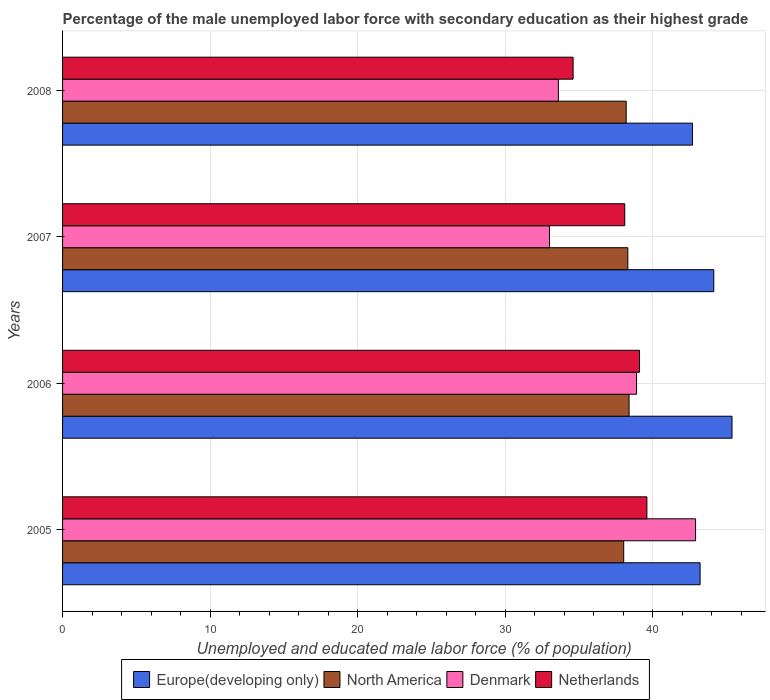How many different coloured bars are there?
Keep it short and to the point. 4. How many bars are there on the 3rd tick from the top?
Provide a short and direct response. 4. How many bars are there on the 3rd tick from the bottom?
Keep it short and to the point. 4. What is the label of the 4th group of bars from the top?
Your response must be concise. 2005. What is the percentage of the unemployed male labor force with secondary education in Europe(developing only) in 2007?
Make the answer very short. 44.13. Across all years, what is the maximum percentage of the unemployed male labor force with secondary education in Denmark?
Offer a very short reply. 42.9. Across all years, what is the minimum percentage of the unemployed male labor force with secondary education in Netherlands?
Your answer should be very brief. 34.6. In which year was the percentage of the unemployed male labor force with secondary education in North America maximum?
Your response must be concise. 2006. What is the total percentage of the unemployed male labor force with secondary education in North America in the graph?
Your response must be concise. 152.93. What is the difference between the percentage of the unemployed male labor force with secondary education in Europe(developing only) in 2005 and that in 2006?
Ensure brevity in your answer.  -2.16. What is the difference between the percentage of the unemployed male labor force with secondary education in Denmark in 2008 and the percentage of the unemployed male labor force with secondary education in North America in 2007?
Your response must be concise. -4.71. What is the average percentage of the unemployed male labor force with secondary education in Denmark per year?
Offer a very short reply. 37.1. In the year 2005, what is the difference between the percentage of the unemployed male labor force with secondary education in Europe(developing only) and percentage of the unemployed male labor force with secondary education in Denmark?
Provide a succinct answer. 0.31. What is the ratio of the percentage of the unemployed male labor force with secondary education in Denmark in 2006 to that in 2008?
Offer a terse response. 1.16. Is the difference between the percentage of the unemployed male labor force with secondary education in Europe(developing only) in 2005 and 2008 greater than the difference between the percentage of the unemployed male labor force with secondary education in Denmark in 2005 and 2008?
Provide a succinct answer. No. What is the difference between the highest and the second highest percentage of the unemployed male labor force with secondary education in Europe(developing only)?
Your response must be concise. 1.24. What is the difference between the highest and the lowest percentage of the unemployed male labor force with secondary education in Denmark?
Offer a terse response. 9.9. In how many years, is the percentage of the unemployed male labor force with secondary education in Denmark greater than the average percentage of the unemployed male labor force with secondary education in Denmark taken over all years?
Provide a short and direct response. 2. How many bars are there?
Keep it short and to the point. 16. Are all the bars in the graph horizontal?
Your answer should be very brief. Yes. Are the values on the major ticks of X-axis written in scientific E-notation?
Provide a short and direct response. No. Does the graph contain any zero values?
Provide a succinct answer. No. Does the graph contain grids?
Make the answer very short. Yes. Where does the legend appear in the graph?
Make the answer very short. Bottom center. How many legend labels are there?
Your response must be concise. 4. How are the legend labels stacked?
Make the answer very short. Horizontal. What is the title of the graph?
Offer a very short reply. Percentage of the male unemployed labor force with secondary education as their highest grade. What is the label or title of the X-axis?
Make the answer very short. Unemployed and educated male labor force (% of population). What is the label or title of the Y-axis?
Keep it short and to the point. Years. What is the Unemployed and educated male labor force (% of population) of Europe(developing only) in 2005?
Your answer should be very brief. 43.21. What is the Unemployed and educated male labor force (% of population) in North America in 2005?
Ensure brevity in your answer.  38.03. What is the Unemployed and educated male labor force (% of population) in Denmark in 2005?
Provide a short and direct response. 42.9. What is the Unemployed and educated male labor force (% of population) of Netherlands in 2005?
Your answer should be very brief. 39.6. What is the Unemployed and educated male labor force (% of population) in Europe(developing only) in 2006?
Your answer should be compact. 45.37. What is the Unemployed and educated male labor force (% of population) in North America in 2006?
Your answer should be compact. 38.39. What is the Unemployed and educated male labor force (% of population) of Denmark in 2006?
Offer a terse response. 38.9. What is the Unemployed and educated male labor force (% of population) of Netherlands in 2006?
Provide a succinct answer. 39.1. What is the Unemployed and educated male labor force (% of population) in Europe(developing only) in 2007?
Offer a very short reply. 44.13. What is the Unemployed and educated male labor force (% of population) in North America in 2007?
Your answer should be compact. 38.31. What is the Unemployed and educated male labor force (% of population) in Denmark in 2007?
Ensure brevity in your answer.  33. What is the Unemployed and educated male labor force (% of population) in Netherlands in 2007?
Offer a very short reply. 38.1. What is the Unemployed and educated male labor force (% of population) of Europe(developing only) in 2008?
Give a very brief answer. 42.69. What is the Unemployed and educated male labor force (% of population) in North America in 2008?
Provide a succinct answer. 38.2. What is the Unemployed and educated male labor force (% of population) of Denmark in 2008?
Your answer should be compact. 33.6. What is the Unemployed and educated male labor force (% of population) of Netherlands in 2008?
Your answer should be compact. 34.6. Across all years, what is the maximum Unemployed and educated male labor force (% of population) in Europe(developing only)?
Give a very brief answer. 45.37. Across all years, what is the maximum Unemployed and educated male labor force (% of population) in North America?
Provide a succinct answer. 38.39. Across all years, what is the maximum Unemployed and educated male labor force (% of population) of Denmark?
Your answer should be compact. 42.9. Across all years, what is the maximum Unemployed and educated male labor force (% of population) of Netherlands?
Ensure brevity in your answer.  39.6. Across all years, what is the minimum Unemployed and educated male labor force (% of population) of Europe(developing only)?
Give a very brief answer. 42.69. Across all years, what is the minimum Unemployed and educated male labor force (% of population) in North America?
Offer a terse response. 38.03. Across all years, what is the minimum Unemployed and educated male labor force (% of population) of Netherlands?
Provide a succinct answer. 34.6. What is the total Unemployed and educated male labor force (% of population) of Europe(developing only) in the graph?
Provide a short and direct response. 175.4. What is the total Unemployed and educated male labor force (% of population) in North America in the graph?
Keep it short and to the point. 152.93. What is the total Unemployed and educated male labor force (% of population) in Denmark in the graph?
Offer a very short reply. 148.4. What is the total Unemployed and educated male labor force (% of population) in Netherlands in the graph?
Offer a terse response. 151.4. What is the difference between the Unemployed and educated male labor force (% of population) of Europe(developing only) in 2005 and that in 2006?
Your answer should be very brief. -2.16. What is the difference between the Unemployed and educated male labor force (% of population) of North America in 2005 and that in 2006?
Offer a terse response. -0.36. What is the difference between the Unemployed and educated male labor force (% of population) of Europe(developing only) in 2005 and that in 2007?
Provide a short and direct response. -0.93. What is the difference between the Unemployed and educated male labor force (% of population) of North America in 2005 and that in 2007?
Your response must be concise. -0.28. What is the difference between the Unemployed and educated male labor force (% of population) of Denmark in 2005 and that in 2007?
Your answer should be compact. 9.9. What is the difference between the Unemployed and educated male labor force (% of population) of Europe(developing only) in 2005 and that in 2008?
Make the answer very short. 0.52. What is the difference between the Unemployed and educated male labor force (% of population) of North America in 2005 and that in 2008?
Provide a short and direct response. -0.17. What is the difference between the Unemployed and educated male labor force (% of population) of Europe(developing only) in 2006 and that in 2007?
Make the answer very short. 1.24. What is the difference between the Unemployed and educated male labor force (% of population) in North America in 2006 and that in 2007?
Keep it short and to the point. 0.08. What is the difference between the Unemployed and educated male labor force (% of population) in Denmark in 2006 and that in 2007?
Keep it short and to the point. 5.9. What is the difference between the Unemployed and educated male labor force (% of population) of Europe(developing only) in 2006 and that in 2008?
Provide a succinct answer. 2.68. What is the difference between the Unemployed and educated male labor force (% of population) in North America in 2006 and that in 2008?
Provide a short and direct response. 0.2. What is the difference between the Unemployed and educated male labor force (% of population) of Denmark in 2006 and that in 2008?
Make the answer very short. 5.3. What is the difference between the Unemployed and educated male labor force (% of population) of Europe(developing only) in 2007 and that in 2008?
Your answer should be very brief. 1.45. What is the difference between the Unemployed and educated male labor force (% of population) in North America in 2007 and that in 2008?
Provide a short and direct response. 0.11. What is the difference between the Unemployed and educated male labor force (% of population) of Netherlands in 2007 and that in 2008?
Provide a short and direct response. 3.5. What is the difference between the Unemployed and educated male labor force (% of population) of Europe(developing only) in 2005 and the Unemployed and educated male labor force (% of population) of North America in 2006?
Provide a short and direct response. 4.81. What is the difference between the Unemployed and educated male labor force (% of population) of Europe(developing only) in 2005 and the Unemployed and educated male labor force (% of population) of Denmark in 2006?
Make the answer very short. 4.31. What is the difference between the Unemployed and educated male labor force (% of population) of Europe(developing only) in 2005 and the Unemployed and educated male labor force (% of population) of Netherlands in 2006?
Offer a very short reply. 4.11. What is the difference between the Unemployed and educated male labor force (% of population) in North America in 2005 and the Unemployed and educated male labor force (% of population) in Denmark in 2006?
Keep it short and to the point. -0.87. What is the difference between the Unemployed and educated male labor force (% of population) in North America in 2005 and the Unemployed and educated male labor force (% of population) in Netherlands in 2006?
Your answer should be compact. -1.07. What is the difference between the Unemployed and educated male labor force (% of population) in Europe(developing only) in 2005 and the Unemployed and educated male labor force (% of population) in North America in 2007?
Your answer should be compact. 4.9. What is the difference between the Unemployed and educated male labor force (% of population) of Europe(developing only) in 2005 and the Unemployed and educated male labor force (% of population) of Denmark in 2007?
Your answer should be compact. 10.21. What is the difference between the Unemployed and educated male labor force (% of population) of Europe(developing only) in 2005 and the Unemployed and educated male labor force (% of population) of Netherlands in 2007?
Your answer should be compact. 5.11. What is the difference between the Unemployed and educated male labor force (% of population) of North America in 2005 and the Unemployed and educated male labor force (% of population) of Denmark in 2007?
Your response must be concise. 5.03. What is the difference between the Unemployed and educated male labor force (% of population) of North America in 2005 and the Unemployed and educated male labor force (% of population) of Netherlands in 2007?
Your response must be concise. -0.07. What is the difference between the Unemployed and educated male labor force (% of population) of Europe(developing only) in 2005 and the Unemployed and educated male labor force (% of population) of North America in 2008?
Give a very brief answer. 5.01. What is the difference between the Unemployed and educated male labor force (% of population) of Europe(developing only) in 2005 and the Unemployed and educated male labor force (% of population) of Denmark in 2008?
Provide a short and direct response. 9.61. What is the difference between the Unemployed and educated male labor force (% of population) in Europe(developing only) in 2005 and the Unemployed and educated male labor force (% of population) in Netherlands in 2008?
Offer a terse response. 8.61. What is the difference between the Unemployed and educated male labor force (% of population) in North America in 2005 and the Unemployed and educated male labor force (% of population) in Denmark in 2008?
Offer a very short reply. 4.43. What is the difference between the Unemployed and educated male labor force (% of population) in North America in 2005 and the Unemployed and educated male labor force (% of population) in Netherlands in 2008?
Give a very brief answer. 3.43. What is the difference between the Unemployed and educated male labor force (% of population) of Europe(developing only) in 2006 and the Unemployed and educated male labor force (% of population) of North America in 2007?
Your response must be concise. 7.06. What is the difference between the Unemployed and educated male labor force (% of population) of Europe(developing only) in 2006 and the Unemployed and educated male labor force (% of population) of Denmark in 2007?
Give a very brief answer. 12.37. What is the difference between the Unemployed and educated male labor force (% of population) in Europe(developing only) in 2006 and the Unemployed and educated male labor force (% of population) in Netherlands in 2007?
Offer a terse response. 7.27. What is the difference between the Unemployed and educated male labor force (% of population) of North America in 2006 and the Unemployed and educated male labor force (% of population) of Denmark in 2007?
Ensure brevity in your answer.  5.39. What is the difference between the Unemployed and educated male labor force (% of population) of North America in 2006 and the Unemployed and educated male labor force (% of population) of Netherlands in 2007?
Your answer should be compact. 0.29. What is the difference between the Unemployed and educated male labor force (% of population) in Europe(developing only) in 2006 and the Unemployed and educated male labor force (% of population) in North America in 2008?
Provide a succinct answer. 7.17. What is the difference between the Unemployed and educated male labor force (% of population) of Europe(developing only) in 2006 and the Unemployed and educated male labor force (% of population) of Denmark in 2008?
Your response must be concise. 11.77. What is the difference between the Unemployed and educated male labor force (% of population) in Europe(developing only) in 2006 and the Unemployed and educated male labor force (% of population) in Netherlands in 2008?
Give a very brief answer. 10.77. What is the difference between the Unemployed and educated male labor force (% of population) in North America in 2006 and the Unemployed and educated male labor force (% of population) in Denmark in 2008?
Make the answer very short. 4.79. What is the difference between the Unemployed and educated male labor force (% of population) in North America in 2006 and the Unemployed and educated male labor force (% of population) in Netherlands in 2008?
Ensure brevity in your answer.  3.79. What is the difference between the Unemployed and educated male labor force (% of population) in Europe(developing only) in 2007 and the Unemployed and educated male labor force (% of population) in North America in 2008?
Offer a terse response. 5.94. What is the difference between the Unemployed and educated male labor force (% of population) in Europe(developing only) in 2007 and the Unemployed and educated male labor force (% of population) in Denmark in 2008?
Give a very brief answer. 10.53. What is the difference between the Unemployed and educated male labor force (% of population) of Europe(developing only) in 2007 and the Unemployed and educated male labor force (% of population) of Netherlands in 2008?
Give a very brief answer. 9.53. What is the difference between the Unemployed and educated male labor force (% of population) of North America in 2007 and the Unemployed and educated male labor force (% of population) of Denmark in 2008?
Make the answer very short. 4.71. What is the difference between the Unemployed and educated male labor force (% of population) in North America in 2007 and the Unemployed and educated male labor force (% of population) in Netherlands in 2008?
Your answer should be compact. 3.71. What is the average Unemployed and educated male labor force (% of population) of Europe(developing only) per year?
Offer a terse response. 43.85. What is the average Unemployed and educated male labor force (% of population) of North America per year?
Keep it short and to the point. 38.23. What is the average Unemployed and educated male labor force (% of population) of Denmark per year?
Ensure brevity in your answer.  37.1. What is the average Unemployed and educated male labor force (% of population) in Netherlands per year?
Your response must be concise. 37.85. In the year 2005, what is the difference between the Unemployed and educated male labor force (% of population) of Europe(developing only) and Unemployed and educated male labor force (% of population) of North America?
Offer a terse response. 5.18. In the year 2005, what is the difference between the Unemployed and educated male labor force (% of population) in Europe(developing only) and Unemployed and educated male labor force (% of population) in Denmark?
Ensure brevity in your answer.  0.31. In the year 2005, what is the difference between the Unemployed and educated male labor force (% of population) of Europe(developing only) and Unemployed and educated male labor force (% of population) of Netherlands?
Provide a short and direct response. 3.61. In the year 2005, what is the difference between the Unemployed and educated male labor force (% of population) of North America and Unemployed and educated male labor force (% of population) of Denmark?
Make the answer very short. -4.87. In the year 2005, what is the difference between the Unemployed and educated male labor force (% of population) of North America and Unemployed and educated male labor force (% of population) of Netherlands?
Provide a succinct answer. -1.57. In the year 2006, what is the difference between the Unemployed and educated male labor force (% of population) in Europe(developing only) and Unemployed and educated male labor force (% of population) in North America?
Provide a short and direct response. 6.98. In the year 2006, what is the difference between the Unemployed and educated male labor force (% of population) of Europe(developing only) and Unemployed and educated male labor force (% of population) of Denmark?
Ensure brevity in your answer.  6.47. In the year 2006, what is the difference between the Unemployed and educated male labor force (% of population) in Europe(developing only) and Unemployed and educated male labor force (% of population) in Netherlands?
Provide a succinct answer. 6.27. In the year 2006, what is the difference between the Unemployed and educated male labor force (% of population) in North America and Unemployed and educated male labor force (% of population) in Denmark?
Make the answer very short. -0.51. In the year 2006, what is the difference between the Unemployed and educated male labor force (% of population) in North America and Unemployed and educated male labor force (% of population) in Netherlands?
Provide a succinct answer. -0.71. In the year 2007, what is the difference between the Unemployed and educated male labor force (% of population) in Europe(developing only) and Unemployed and educated male labor force (% of population) in North America?
Your answer should be very brief. 5.82. In the year 2007, what is the difference between the Unemployed and educated male labor force (% of population) of Europe(developing only) and Unemployed and educated male labor force (% of population) of Denmark?
Ensure brevity in your answer.  11.13. In the year 2007, what is the difference between the Unemployed and educated male labor force (% of population) in Europe(developing only) and Unemployed and educated male labor force (% of population) in Netherlands?
Your answer should be very brief. 6.03. In the year 2007, what is the difference between the Unemployed and educated male labor force (% of population) of North America and Unemployed and educated male labor force (% of population) of Denmark?
Offer a terse response. 5.31. In the year 2007, what is the difference between the Unemployed and educated male labor force (% of population) of North America and Unemployed and educated male labor force (% of population) of Netherlands?
Provide a short and direct response. 0.21. In the year 2007, what is the difference between the Unemployed and educated male labor force (% of population) of Denmark and Unemployed and educated male labor force (% of population) of Netherlands?
Offer a very short reply. -5.1. In the year 2008, what is the difference between the Unemployed and educated male labor force (% of population) of Europe(developing only) and Unemployed and educated male labor force (% of population) of North America?
Give a very brief answer. 4.49. In the year 2008, what is the difference between the Unemployed and educated male labor force (% of population) in Europe(developing only) and Unemployed and educated male labor force (% of population) in Denmark?
Offer a terse response. 9.09. In the year 2008, what is the difference between the Unemployed and educated male labor force (% of population) in Europe(developing only) and Unemployed and educated male labor force (% of population) in Netherlands?
Keep it short and to the point. 8.09. In the year 2008, what is the difference between the Unemployed and educated male labor force (% of population) in North America and Unemployed and educated male labor force (% of population) in Denmark?
Make the answer very short. 4.6. In the year 2008, what is the difference between the Unemployed and educated male labor force (% of population) in North America and Unemployed and educated male labor force (% of population) in Netherlands?
Offer a very short reply. 3.6. In the year 2008, what is the difference between the Unemployed and educated male labor force (% of population) in Denmark and Unemployed and educated male labor force (% of population) in Netherlands?
Offer a terse response. -1. What is the ratio of the Unemployed and educated male labor force (% of population) in Europe(developing only) in 2005 to that in 2006?
Keep it short and to the point. 0.95. What is the ratio of the Unemployed and educated male labor force (% of population) in Denmark in 2005 to that in 2006?
Give a very brief answer. 1.1. What is the ratio of the Unemployed and educated male labor force (% of population) in Netherlands in 2005 to that in 2006?
Provide a short and direct response. 1.01. What is the ratio of the Unemployed and educated male labor force (% of population) in Europe(developing only) in 2005 to that in 2007?
Make the answer very short. 0.98. What is the ratio of the Unemployed and educated male labor force (% of population) in North America in 2005 to that in 2007?
Keep it short and to the point. 0.99. What is the ratio of the Unemployed and educated male labor force (% of population) in Netherlands in 2005 to that in 2007?
Your answer should be very brief. 1.04. What is the ratio of the Unemployed and educated male labor force (% of population) of Europe(developing only) in 2005 to that in 2008?
Your answer should be compact. 1.01. What is the ratio of the Unemployed and educated male labor force (% of population) of North America in 2005 to that in 2008?
Make the answer very short. 1. What is the ratio of the Unemployed and educated male labor force (% of population) in Denmark in 2005 to that in 2008?
Ensure brevity in your answer.  1.28. What is the ratio of the Unemployed and educated male labor force (% of population) of Netherlands in 2005 to that in 2008?
Ensure brevity in your answer.  1.14. What is the ratio of the Unemployed and educated male labor force (% of population) in Europe(developing only) in 2006 to that in 2007?
Your answer should be compact. 1.03. What is the ratio of the Unemployed and educated male labor force (% of population) in North America in 2006 to that in 2007?
Provide a short and direct response. 1. What is the ratio of the Unemployed and educated male labor force (% of population) in Denmark in 2006 to that in 2007?
Keep it short and to the point. 1.18. What is the ratio of the Unemployed and educated male labor force (% of population) in Netherlands in 2006 to that in 2007?
Your answer should be compact. 1.03. What is the ratio of the Unemployed and educated male labor force (% of population) in Europe(developing only) in 2006 to that in 2008?
Provide a short and direct response. 1.06. What is the ratio of the Unemployed and educated male labor force (% of population) in North America in 2006 to that in 2008?
Provide a succinct answer. 1.01. What is the ratio of the Unemployed and educated male labor force (% of population) in Denmark in 2006 to that in 2008?
Offer a very short reply. 1.16. What is the ratio of the Unemployed and educated male labor force (% of population) in Netherlands in 2006 to that in 2008?
Keep it short and to the point. 1.13. What is the ratio of the Unemployed and educated male labor force (% of population) of Europe(developing only) in 2007 to that in 2008?
Ensure brevity in your answer.  1.03. What is the ratio of the Unemployed and educated male labor force (% of population) in Denmark in 2007 to that in 2008?
Make the answer very short. 0.98. What is the ratio of the Unemployed and educated male labor force (% of population) in Netherlands in 2007 to that in 2008?
Your answer should be very brief. 1.1. What is the difference between the highest and the second highest Unemployed and educated male labor force (% of population) in Europe(developing only)?
Your answer should be very brief. 1.24. What is the difference between the highest and the second highest Unemployed and educated male labor force (% of population) in North America?
Give a very brief answer. 0.08. What is the difference between the highest and the lowest Unemployed and educated male labor force (% of population) of Europe(developing only)?
Make the answer very short. 2.68. What is the difference between the highest and the lowest Unemployed and educated male labor force (% of population) in North America?
Provide a short and direct response. 0.36. 